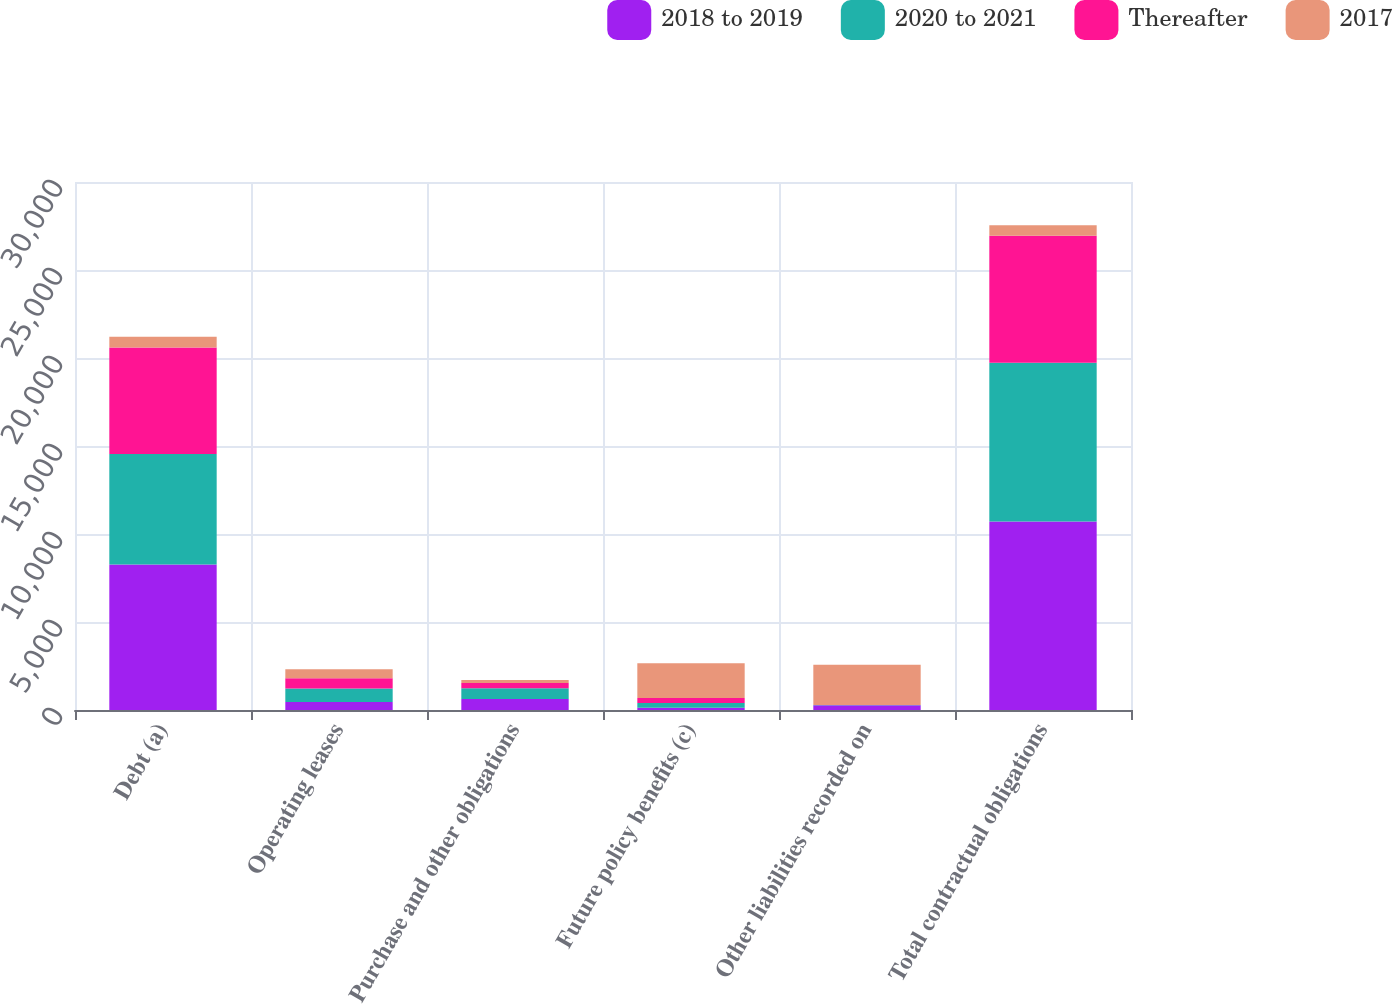Convert chart to OTSL. <chart><loc_0><loc_0><loc_500><loc_500><stacked_bar_chart><ecel><fcel>Debt (a)<fcel>Operating leases<fcel>Purchase and other obligations<fcel>Future policy benefits (c)<fcel>Other liabilities recorded on<fcel>Total contractual obligations<nl><fcel>2018 to 2019<fcel>8262<fcel>453<fcel>623<fcel>133<fcel>269<fcel>10717<nl><fcel>2020 to 2021<fcel>6282<fcel>771<fcel>617<fcel>271<fcel>14<fcel>9009<nl><fcel>Thereafter<fcel>6059<fcel>587<fcel>297<fcel>273<fcel>5<fcel>7221<nl><fcel>2017<fcel>602<fcel>499<fcel>170<fcel>1980<fcel>2288<fcel>602<nl></chart> 